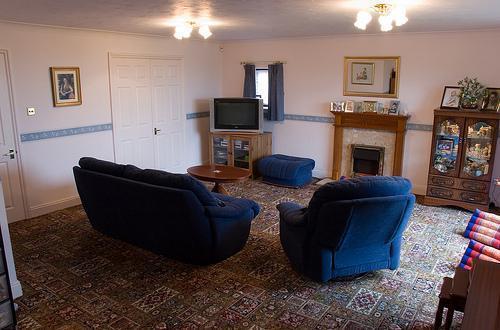How many chairs are there?
Give a very brief answer. 2. How many TV's are there?
Give a very brief answer. 1. 